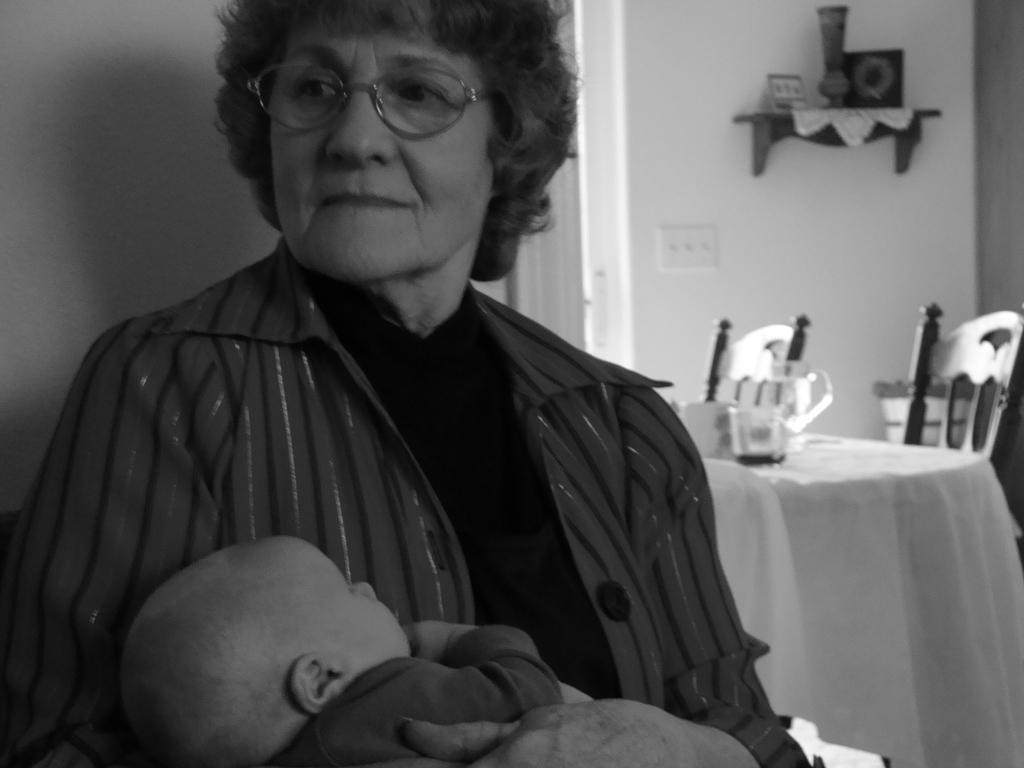Who is the main subject in the image? There is a woman in the image. What is the woman doing in the image? The woman is holding a baby. What is the woman wearing in the image? The woman is wearing a coat. What type of furniture can be seen on the right side of the image? There are chairs present on the right side of the image. What is the primary purpose of the furniture in the image? The chairs and the dining table suggest a dining or gathering area. What can be seen on the dining table? There is a glass on the dining table. What type of paste is being used by the woman in the image? There is no paste visible in the image; the woman is holding a baby. 